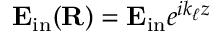Convert formula to latex. <formula><loc_0><loc_0><loc_500><loc_500>\mathbf E _ { i n } ( \mathbf R ) = \mathbf E _ { i n } e ^ { i k _ { \ell } z }</formula> 